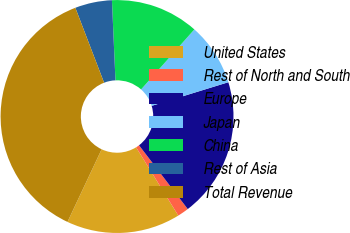Convert chart to OTSL. <chart><loc_0><loc_0><loc_500><loc_500><pie_chart><fcel>United States<fcel>Rest of North and South<fcel>Europe<fcel>Japan<fcel>China<fcel>Rest of Asia<fcel>Total Revenue<nl><fcel>15.81%<fcel>1.57%<fcel>19.37%<fcel>8.69%<fcel>12.25%<fcel>5.13%<fcel>37.17%<nl></chart> 